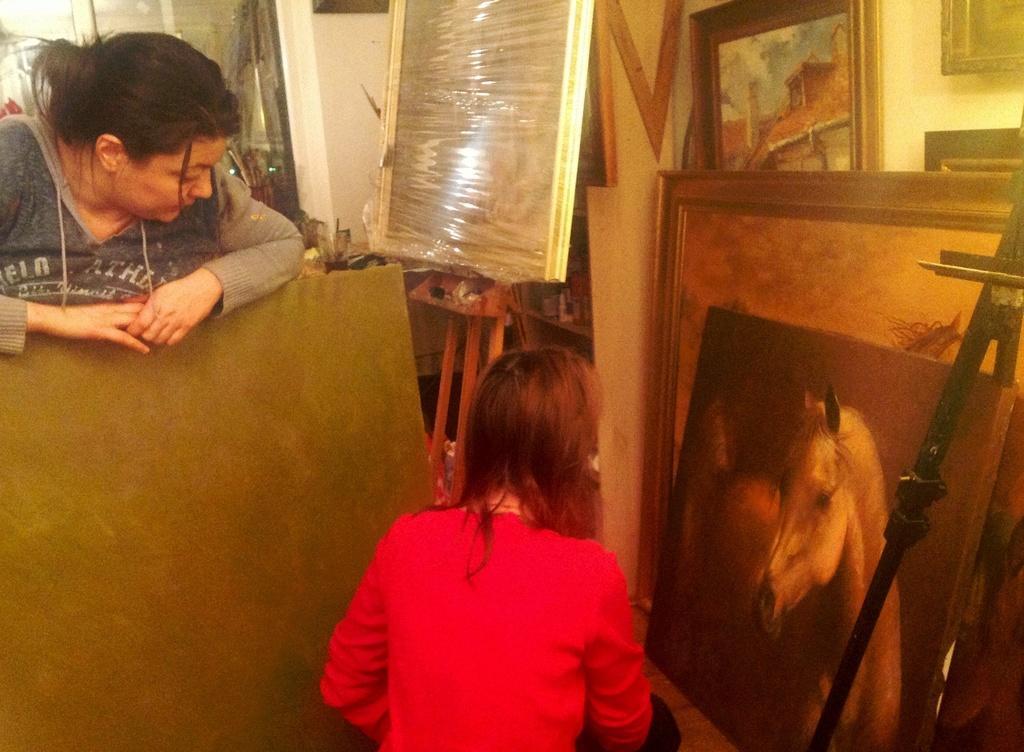Can you describe this image briefly? In this image I can see two people. I can see the wall, few frames, few objects and the board is on the stand. 